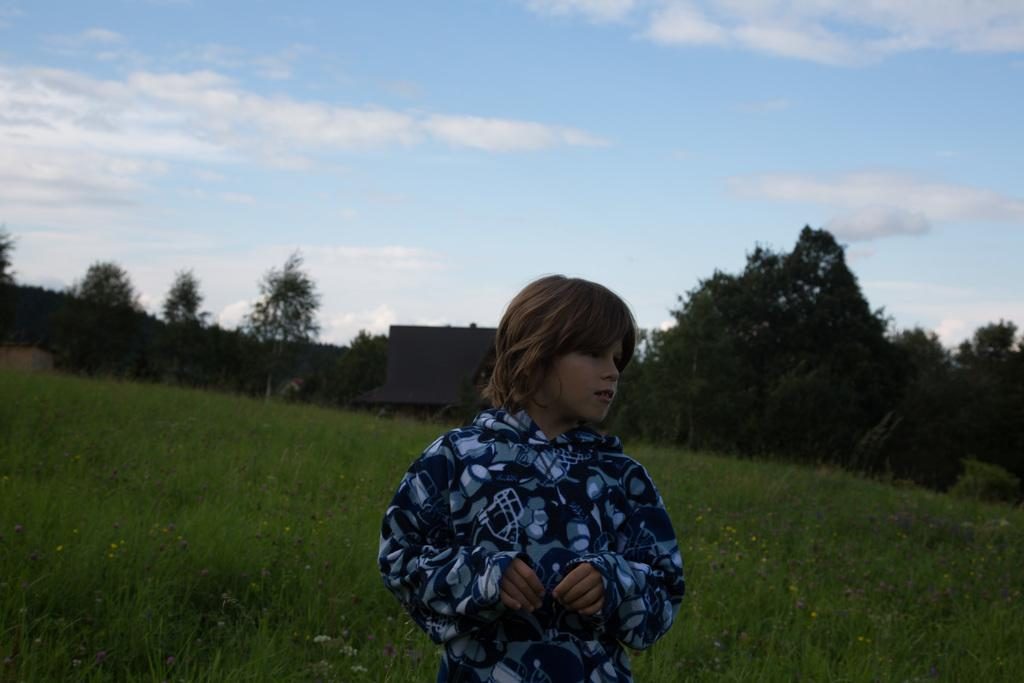Who is the main subject in the front of the image? There is a boy in the front of the image. What can be seen in the background of the image? There are trees, a building, and grass in the background of the image. What is the condition of the sky in the image? The sky is cloudy in the image. What type of pear is hanging from the curtain in the image? There is no pear or curtain present in the image. Can you tell me which actor is playing the role of the boy in the image? The image is not a photograph or video, so there is no actor playing the role of the boy. 